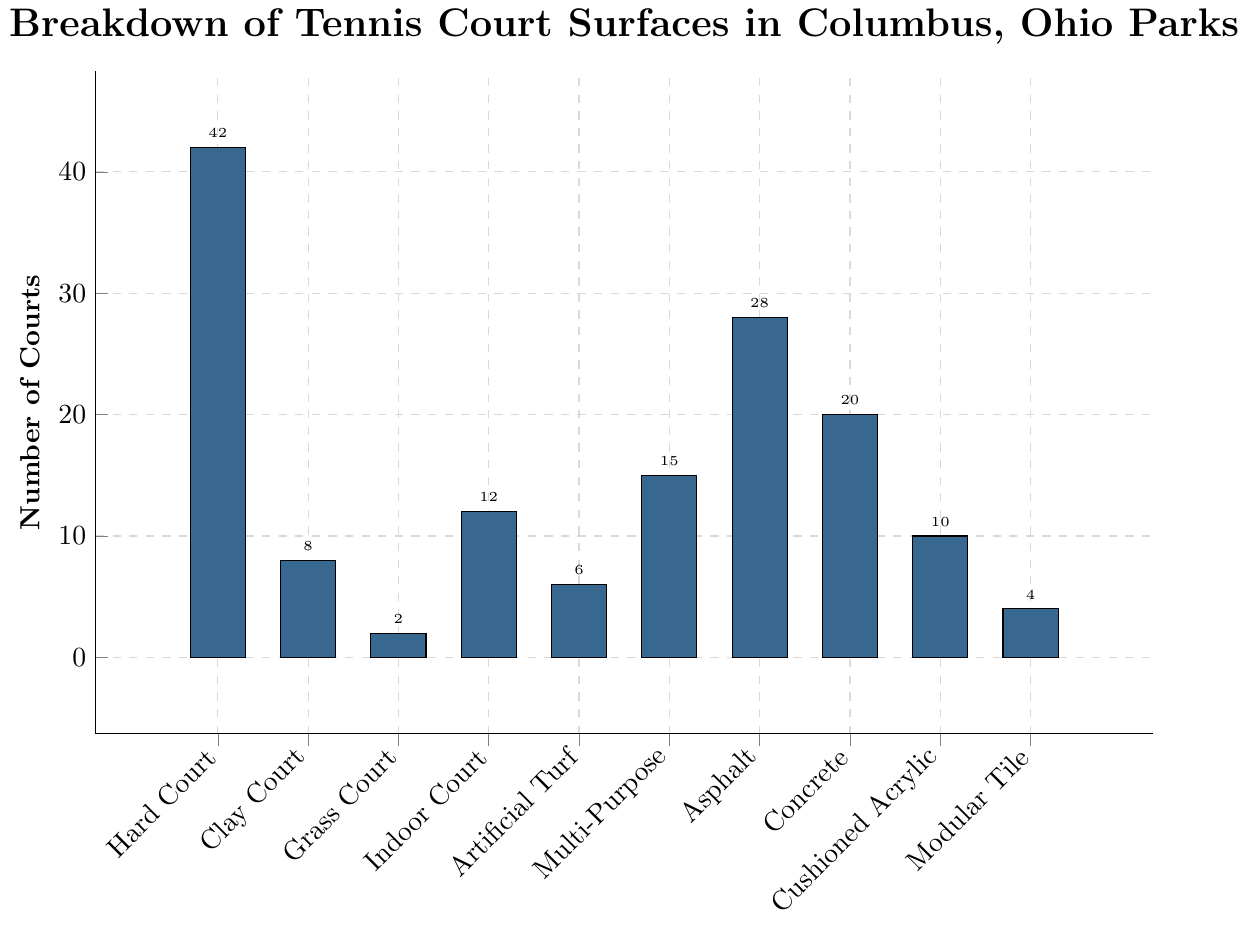Which surface type has the largest number of courts? The bar representing "Hard Court" is the tallest in the chart, indicating the largest number of courts.
Answer: Hard Court How many more Asphalt courts are there compared to Clay courts? The number of Asphalt courts is 28 and the number of Clay courts is 8. The difference is 28 - 8.
Answer: 20 What is the combined total of Indoor Court and Artificial Turf courts? The number of Indoor Court courts is 12 and the number of Artificial Turf courts is 6. The combined total is 12 + 6.
Answer: 18 Which surface type has the fewest courts, and how many does it have? The bar representing "Grass Court" is the shortest in the chart, indicating the fewest number of courts.
Answer: Grass Court, 2 Are there more Concrete courts or Cushioned Acrylic courts? The height of the bar for Concrete courts is higher than that of Cushioned Acrylic courts. Concrete courts are 20 and Cushioned Acrylic courts are 10.
Answer: Concrete Which two surface types have nearly the same number of courts? The bars representing Modular Tile and Grass Court are close in height. Modular Tile has 4 courts and Grass Court has 2 courts.
Answer: Modular Tile and Grass Court What is the average number of courts across all surface types? The total number of courts is 147. There are 10 surface types. The average is 147 / 10.
Answer: 14.7 What is the difference in the number of courts between the highest and the lowest surface types? The highest is "Hard Court" with 42 courts and the lowest is "Grass Court" with 2 courts. The difference is 42 - 2.
Answer: 40 How many surface types have more than 10 courts each? The surface types with more than 10 courts are Hard Court (42), Indoor Court (12), Multi-Purpose (15), Asphalt (28), and Concrete (20). There are 5 such types.
Answer: 5 If you combine the number of courts from the two types with the least courts, what percentage of the total number of courts does this represent? The two types with the least courts are Grass Court (2) and Modular Tile (4). Their total is 2 + 4 = 6. The total number of courts is 147. The percentage is (6 / 147) * 100%.
Answer: ≈ 4.08% 